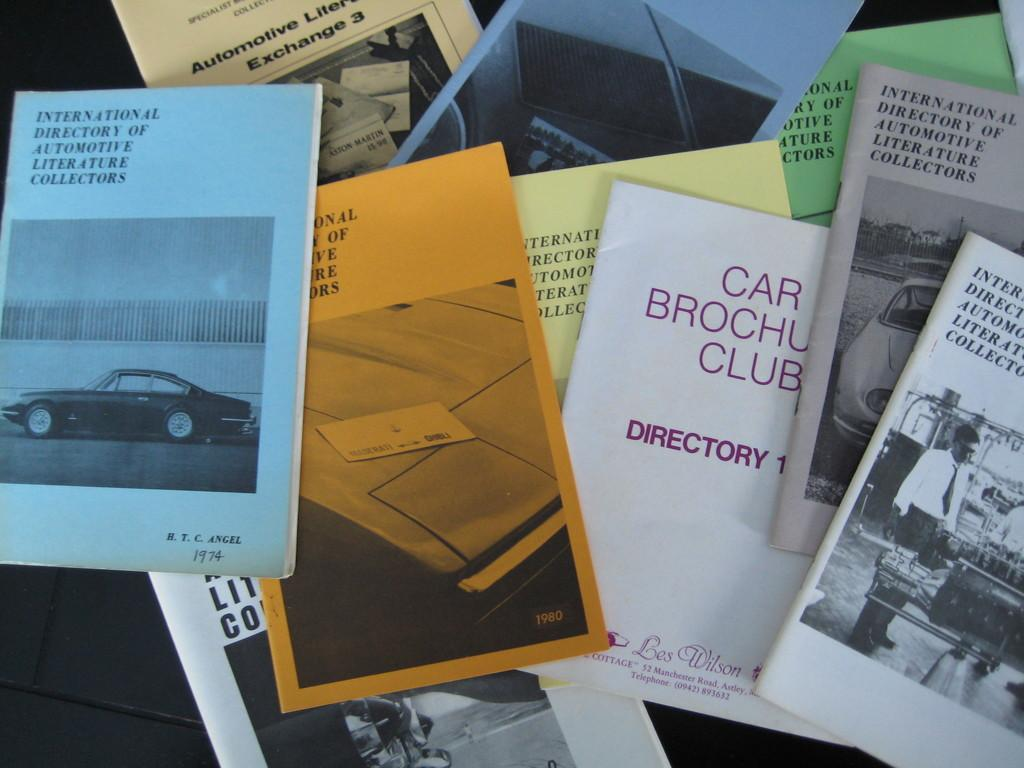Provide a one-sentence caption for the provided image. A bunch of pamphlets rest on a laptop including one titled Car Brochure Club. 